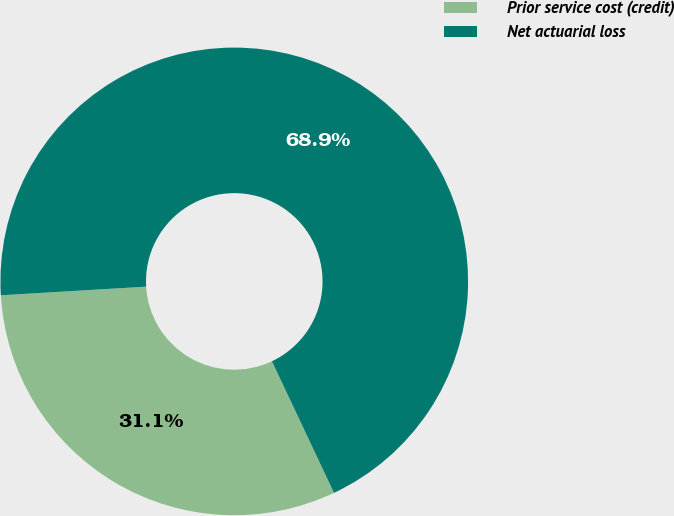Convert chart to OTSL. <chart><loc_0><loc_0><loc_500><loc_500><pie_chart><fcel>Prior service cost (credit)<fcel>Net actuarial loss<nl><fcel>31.07%<fcel>68.93%<nl></chart> 